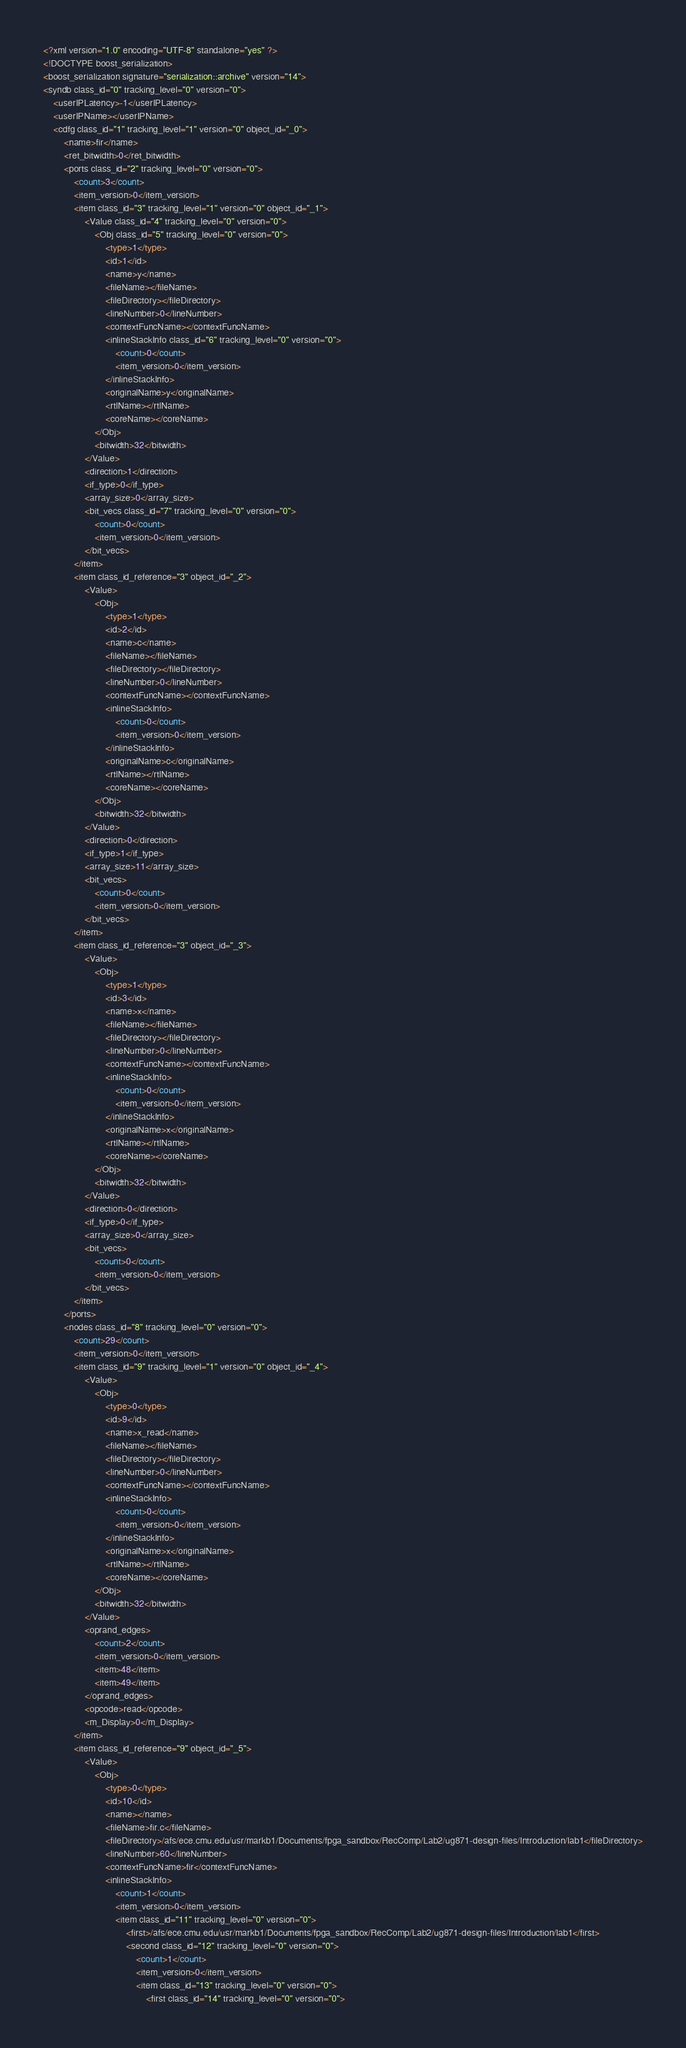<code> <loc_0><loc_0><loc_500><loc_500><_Ada_><?xml version="1.0" encoding="UTF-8" standalone="yes" ?>
<!DOCTYPE boost_serialization>
<boost_serialization signature="serialization::archive" version="14">
<syndb class_id="0" tracking_level="0" version="0">
	<userIPLatency>-1</userIPLatency>
	<userIPName></userIPName>
	<cdfg class_id="1" tracking_level="1" version="0" object_id="_0">
		<name>fir</name>
		<ret_bitwidth>0</ret_bitwidth>
		<ports class_id="2" tracking_level="0" version="0">
			<count>3</count>
			<item_version>0</item_version>
			<item class_id="3" tracking_level="1" version="0" object_id="_1">
				<Value class_id="4" tracking_level="0" version="0">
					<Obj class_id="5" tracking_level="0" version="0">
						<type>1</type>
						<id>1</id>
						<name>y</name>
						<fileName></fileName>
						<fileDirectory></fileDirectory>
						<lineNumber>0</lineNumber>
						<contextFuncName></contextFuncName>
						<inlineStackInfo class_id="6" tracking_level="0" version="0">
							<count>0</count>
							<item_version>0</item_version>
						</inlineStackInfo>
						<originalName>y</originalName>
						<rtlName></rtlName>
						<coreName></coreName>
					</Obj>
					<bitwidth>32</bitwidth>
				</Value>
				<direction>1</direction>
				<if_type>0</if_type>
				<array_size>0</array_size>
				<bit_vecs class_id="7" tracking_level="0" version="0">
					<count>0</count>
					<item_version>0</item_version>
				</bit_vecs>
			</item>
			<item class_id_reference="3" object_id="_2">
				<Value>
					<Obj>
						<type>1</type>
						<id>2</id>
						<name>c</name>
						<fileName></fileName>
						<fileDirectory></fileDirectory>
						<lineNumber>0</lineNumber>
						<contextFuncName></contextFuncName>
						<inlineStackInfo>
							<count>0</count>
							<item_version>0</item_version>
						</inlineStackInfo>
						<originalName>c</originalName>
						<rtlName></rtlName>
						<coreName></coreName>
					</Obj>
					<bitwidth>32</bitwidth>
				</Value>
				<direction>0</direction>
				<if_type>1</if_type>
				<array_size>11</array_size>
				<bit_vecs>
					<count>0</count>
					<item_version>0</item_version>
				</bit_vecs>
			</item>
			<item class_id_reference="3" object_id="_3">
				<Value>
					<Obj>
						<type>1</type>
						<id>3</id>
						<name>x</name>
						<fileName></fileName>
						<fileDirectory></fileDirectory>
						<lineNumber>0</lineNumber>
						<contextFuncName></contextFuncName>
						<inlineStackInfo>
							<count>0</count>
							<item_version>0</item_version>
						</inlineStackInfo>
						<originalName>x</originalName>
						<rtlName></rtlName>
						<coreName></coreName>
					</Obj>
					<bitwidth>32</bitwidth>
				</Value>
				<direction>0</direction>
				<if_type>0</if_type>
				<array_size>0</array_size>
				<bit_vecs>
					<count>0</count>
					<item_version>0</item_version>
				</bit_vecs>
			</item>
		</ports>
		<nodes class_id="8" tracking_level="0" version="0">
			<count>29</count>
			<item_version>0</item_version>
			<item class_id="9" tracking_level="1" version="0" object_id="_4">
				<Value>
					<Obj>
						<type>0</type>
						<id>9</id>
						<name>x_read</name>
						<fileName></fileName>
						<fileDirectory></fileDirectory>
						<lineNumber>0</lineNumber>
						<contextFuncName></contextFuncName>
						<inlineStackInfo>
							<count>0</count>
							<item_version>0</item_version>
						</inlineStackInfo>
						<originalName>x</originalName>
						<rtlName></rtlName>
						<coreName></coreName>
					</Obj>
					<bitwidth>32</bitwidth>
				</Value>
				<oprand_edges>
					<count>2</count>
					<item_version>0</item_version>
					<item>48</item>
					<item>49</item>
				</oprand_edges>
				<opcode>read</opcode>
				<m_Display>0</m_Display>
			</item>
			<item class_id_reference="9" object_id="_5">
				<Value>
					<Obj>
						<type>0</type>
						<id>10</id>
						<name></name>
						<fileName>fir.c</fileName>
						<fileDirectory>/afs/ece.cmu.edu/usr/markb1/Documents/fpga_sandbox/RecComp/Lab2/ug871-design-files/Introduction/lab1</fileDirectory>
						<lineNumber>60</lineNumber>
						<contextFuncName>fir</contextFuncName>
						<inlineStackInfo>
							<count>1</count>
							<item_version>0</item_version>
							<item class_id="11" tracking_level="0" version="0">
								<first>/afs/ece.cmu.edu/usr/markb1/Documents/fpga_sandbox/RecComp/Lab2/ug871-design-files/Introduction/lab1</first>
								<second class_id="12" tracking_level="0" version="0">
									<count>1</count>
									<item_version>0</item_version>
									<item class_id="13" tracking_level="0" version="0">
										<first class_id="14" tracking_level="0" version="0"></code> 